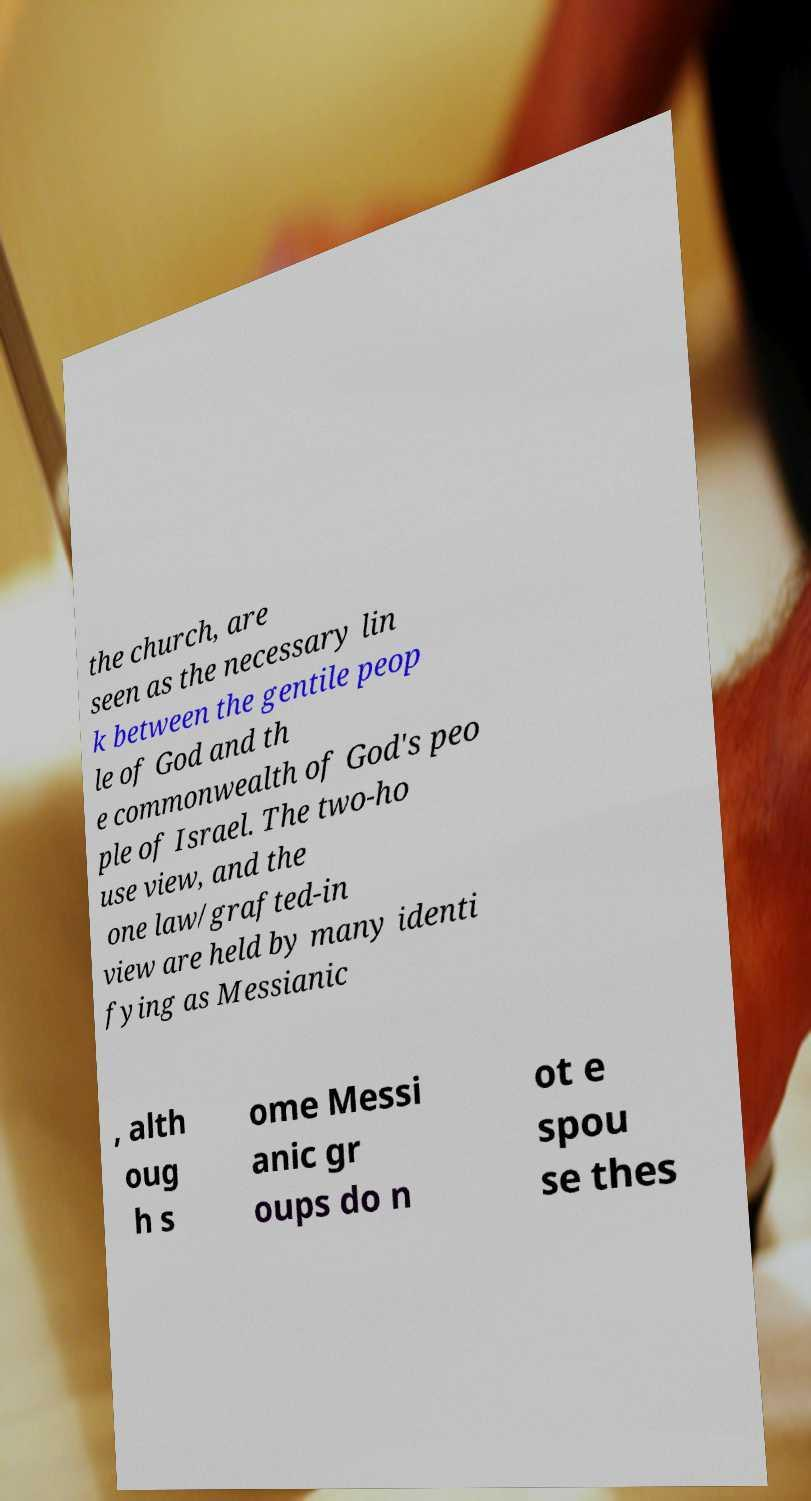Could you assist in decoding the text presented in this image and type it out clearly? the church, are seen as the necessary lin k between the gentile peop le of God and th e commonwealth of God's peo ple of Israel. The two-ho use view, and the one law/grafted-in view are held by many identi fying as Messianic , alth oug h s ome Messi anic gr oups do n ot e spou se thes 